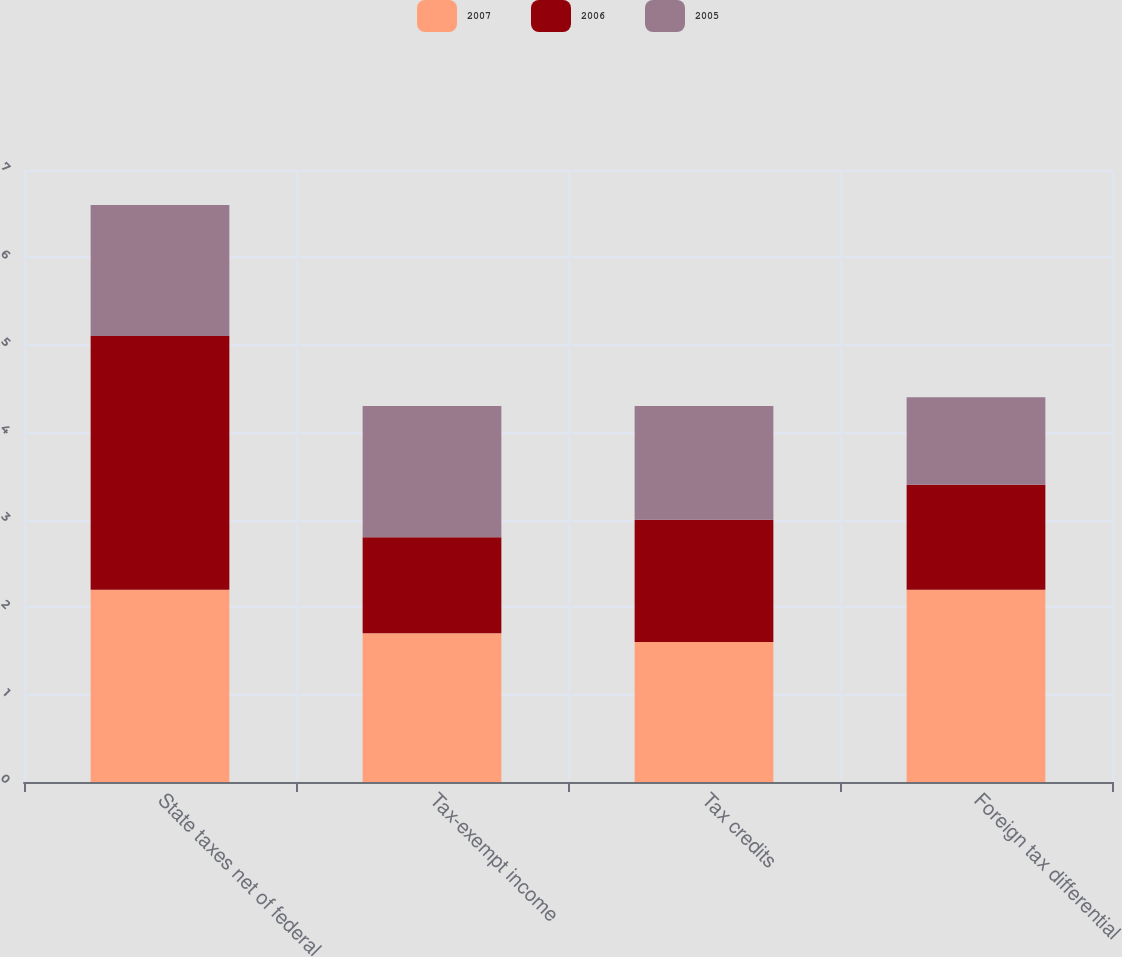<chart> <loc_0><loc_0><loc_500><loc_500><stacked_bar_chart><ecel><fcel>State taxes net of federal<fcel>Tax-exempt income<fcel>Tax credits<fcel>Foreign tax differential<nl><fcel>2007<fcel>2.2<fcel>1.7<fcel>1.6<fcel>2.2<nl><fcel>2006<fcel>2.9<fcel>1.1<fcel>1.4<fcel>1.2<nl><fcel>2005<fcel>1.5<fcel>1.5<fcel>1.3<fcel>1<nl></chart> 